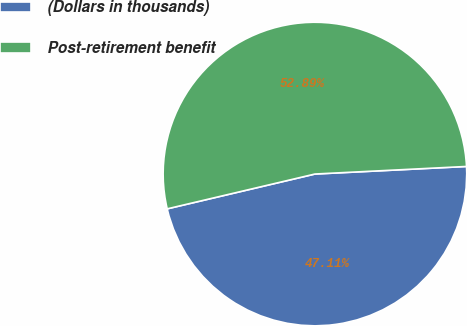Convert chart. <chart><loc_0><loc_0><loc_500><loc_500><pie_chart><fcel>(Dollars in thousands)<fcel>Post-retirement benefit<nl><fcel>47.11%<fcel>52.89%<nl></chart> 